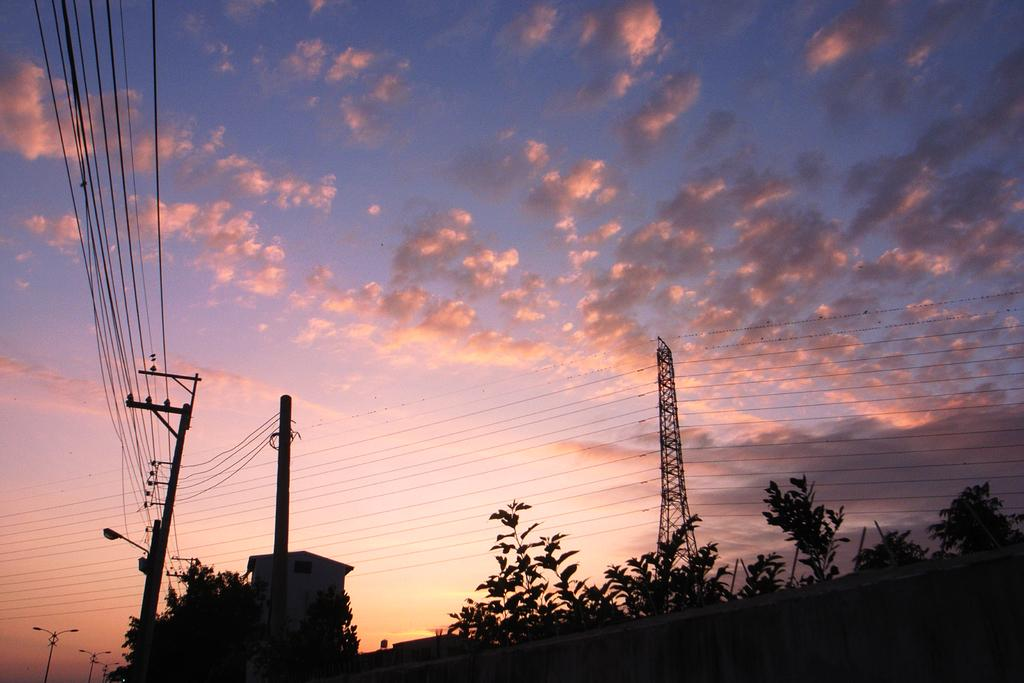What structures can be seen in the image? There are poles, a tower, and a wall at the bottom of the image. What else can be seen in the image? There are trees, a pillar, and street lights at the bottom of the image. What is present in the sky in the image? The background of the image includes a cloudy sky. What is connecting the poles and tower in the image? There are wires connecting the poles and tower in the image. What word is being spoken by the person in the image? There is no person present in the image, so it is not possible to determine what word might be spoken. What type of tray can be seen on the table in the image? There is no table or tray present in the image. 